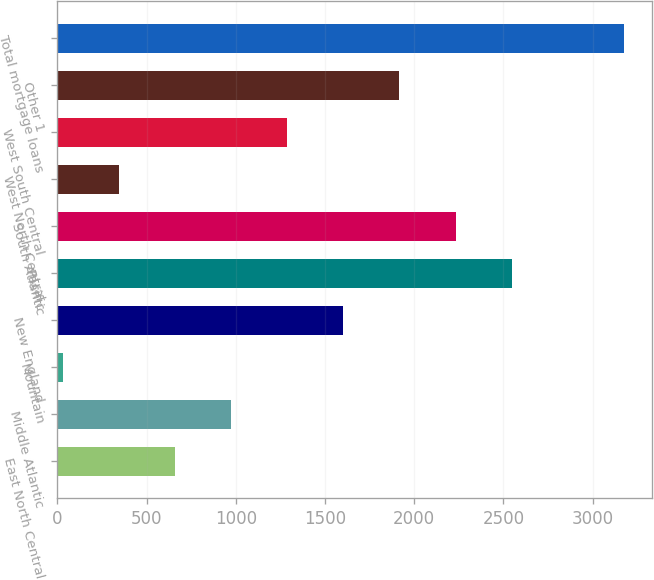Convert chart to OTSL. <chart><loc_0><loc_0><loc_500><loc_500><bar_chart><fcel>East North Central<fcel>Middle Atlantic<fcel>Mountain<fcel>New England<fcel>Pacific<fcel>South Atlantic<fcel>West North Central<fcel>West South Central<fcel>Other 1<fcel>Total mortgage loans<nl><fcel>659.8<fcel>974.2<fcel>31<fcel>1603<fcel>2546.2<fcel>2231.8<fcel>345.4<fcel>1288.6<fcel>1917.4<fcel>3175<nl></chart> 